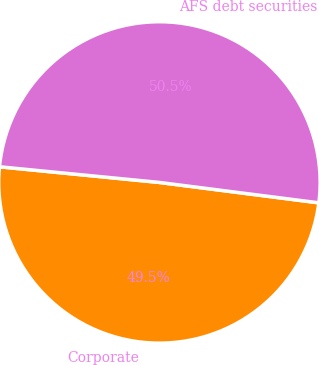Convert chart to OTSL. <chart><loc_0><loc_0><loc_500><loc_500><pie_chart><fcel>Corporate<fcel>AFS debt securities<nl><fcel>49.53%<fcel>50.47%<nl></chart> 